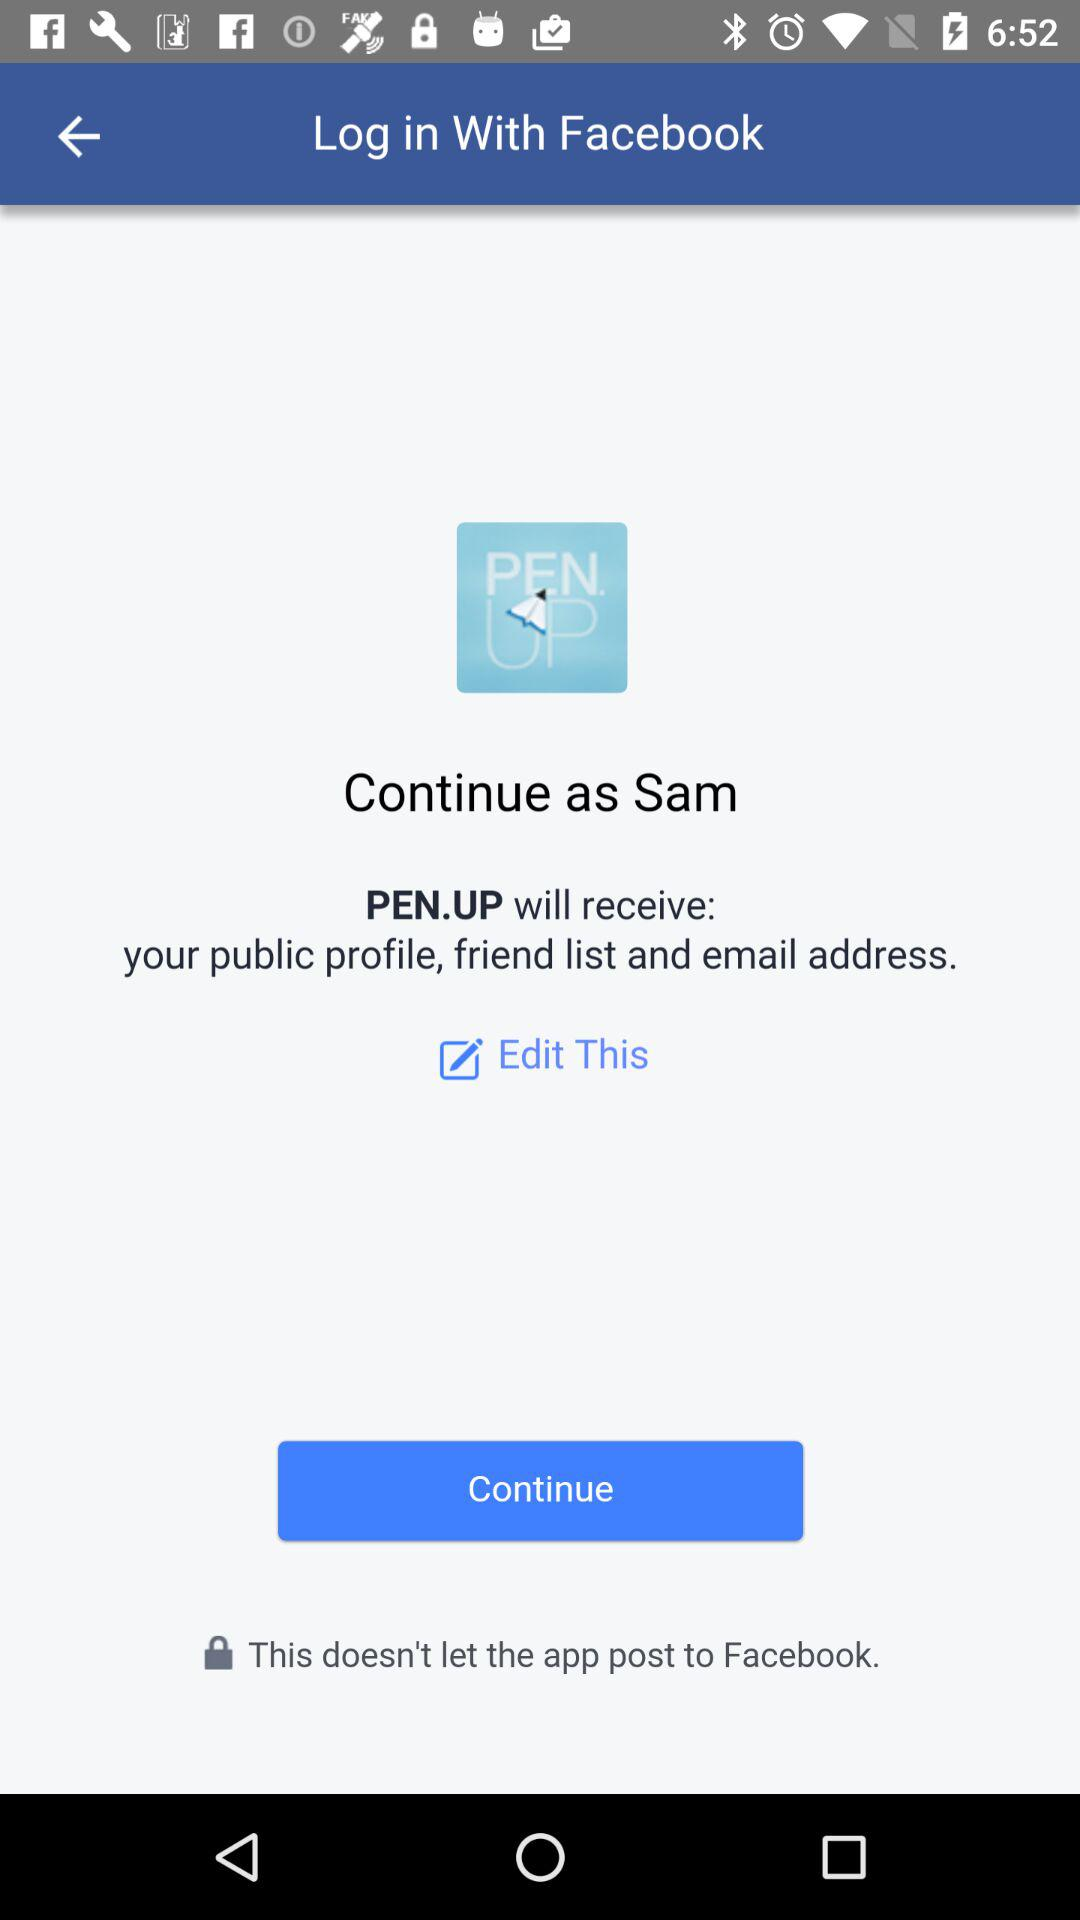What application is asking for permission? The application asking for permission is "PEN.UP". 